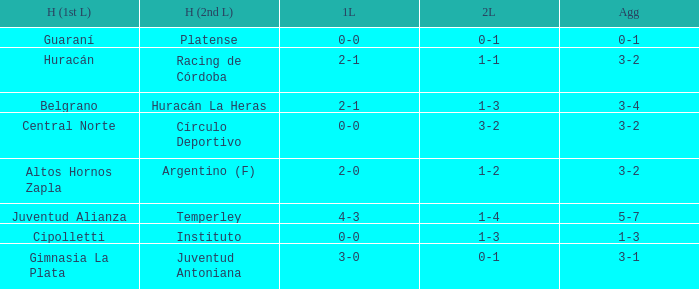Who played at home for the second leg with a score of 0-1 and tied 0-0 in the first leg? Platense. Could you help me parse every detail presented in this table? {'header': ['H (1st L)', 'H (2nd L)', '1L', '2L', 'Agg'], 'rows': [['Guaraní', 'Platense', '0-0', '0-1', '0-1'], ['Huracán', 'Racing de Córdoba', '2-1', '1-1', '3-2'], ['Belgrano', 'Huracán La Heras', '2-1', '1-3', '3-4'], ['Central Norte', 'Círculo Deportivo', '0-0', '3-2', '3-2'], ['Altos Hornos Zapla', 'Argentino (F)', '2-0', '1-2', '3-2'], ['Juventud Alianza', 'Temperley', '4-3', '1-4', '5-7'], ['Cipolletti', 'Instituto', '0-0', '1-3', '1-3'], ['Gimnasia La Plata', 'Juventud Antoniana', '3-0', '0-1', '3-1']]} 